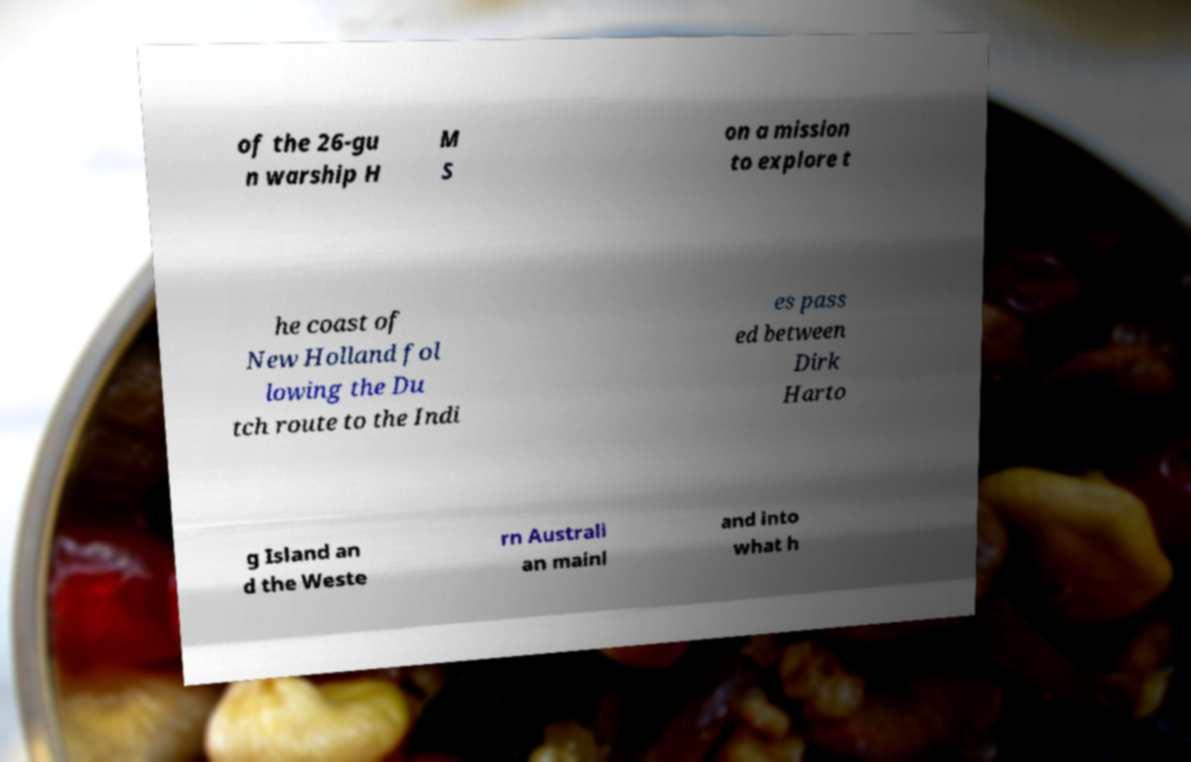Please identify and transcribe the text found in this image. of the 26-gu n warship H M S on a mission to explore t he coast of New Holland fol lowing the Du tch route to the Indi es pass ed between Dirk Harto g Island an d the Weste rn Australi an mainl and into what h 